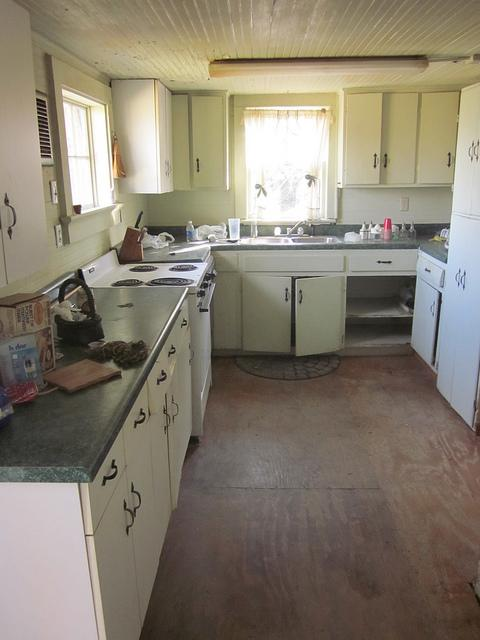What is the black and white object to the left of the window? stove 